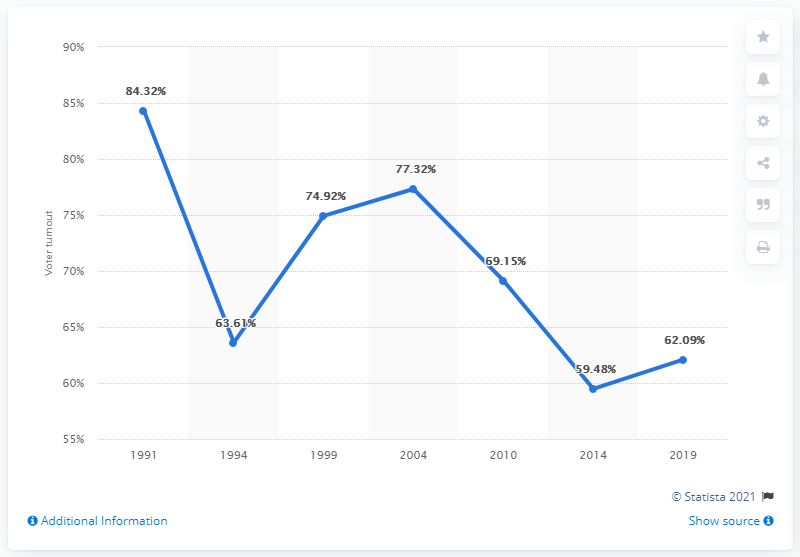Give some essential details in this illustration. In 2014, the voter turnout was 59.48%. In the first national election of 1991 in Ukraine, 84.32% of the population cast their vote. Ukraine became independent in 1991. 